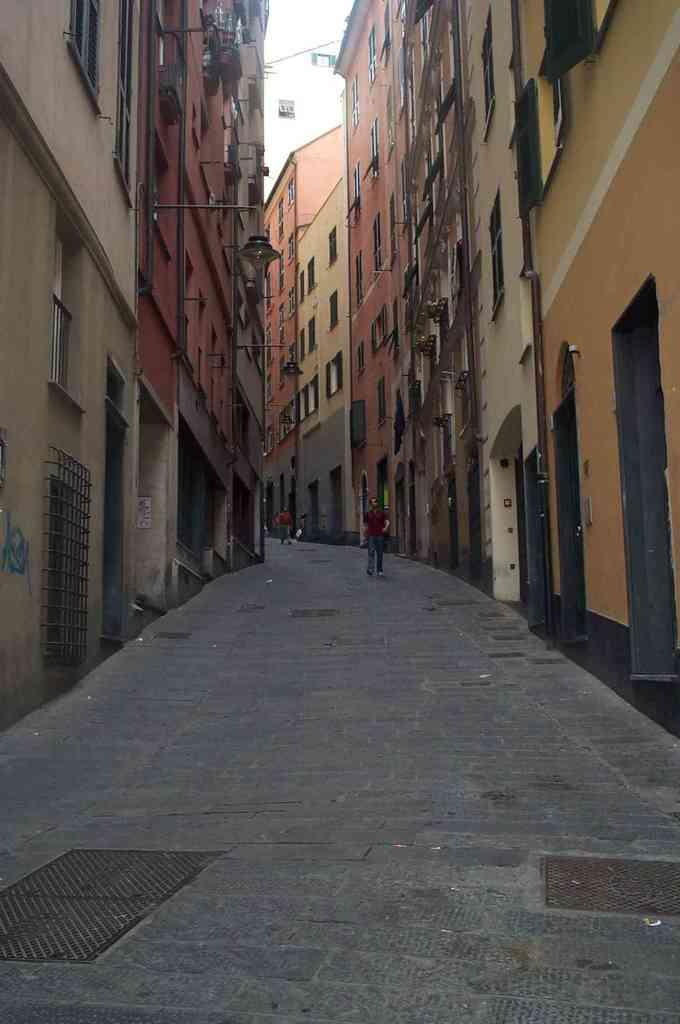What is the main setting of the image? There is a street in the image. What are the people in the image doing? There are people walking along the street. What can be seen on the left side of the image? There are buildings on the left side of the image. What can be seen on the right side of the image? There are buildings on the right side of the image. How many trucks are parked on the edge of the street in the image? There are no trucks visible in the image. What type of beetle can be seen crawling on the sidewalk in the image? There is no beetle present in the image. 